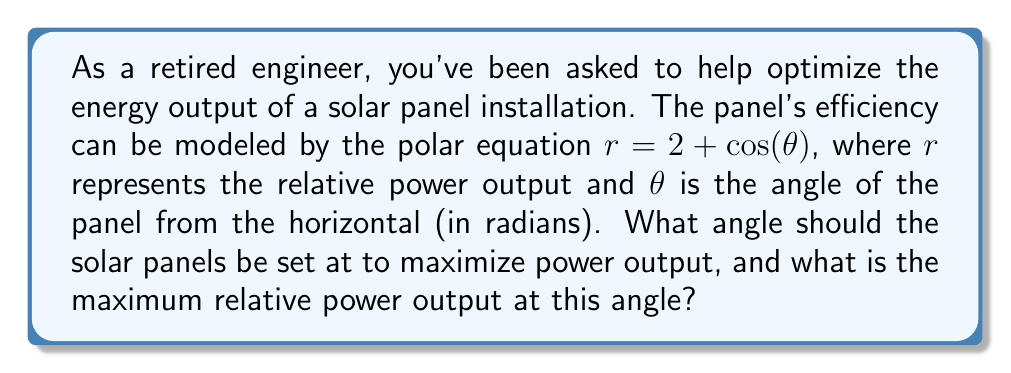Show me your answer to this math problem. To solve this problem, we need to find the maximum value of $r$ in the given polar equation. This can be done by following these steps:

1) The polar equation is given as:
   $$r = 2 + \cos(\theta)$$

2) To find the maximum value of $r$, we need to find where $\frac{dr}{d\theta} = 0$:
   $$\frac{dr}{d\theta} = -\sin(\theta)$$

3) Setting this equal to zero:
   $$-\sin(\theta) = 0$$

4) The sine function is zero when $\theta = 0, \pi, 2\pi, \text{etc.}$ In the context of solar panels, we're interested in the angle between 0 and $\pi$ (0° to 180°).

5) To determine which of these gives the maximum, we can check the second derivative:
   $$\frac{d^2r}{d\theta^2} = -\cos(\theta)$$

6) At $\theta = 0$, $\frac{d^2r}{d\theta^2} = -1 < 0$, indicating a maximum.
   At $\theta = \pi$, $\frac{d^2r}{d\theta^2} = 1 > 0$, indicating a minimum.

7) Therefore, the maximum occurs at $\theta = 0$ radians or 0°.

8) To find the maximum relative power output, we substitute $\theta = 0$ into the original equation:
   $$r = 2 + \cos(0) = 2 + 1 = 3$$

[asy]
import graph;
size(200);
real r(real t) {return 2+cos(t);}
draw(polargraph(r,0,2pi,operator ..),blue);
dot((3,0),red);
label("Maximum at $\theta = 0$, $r = 3$",(3,0),E);
[/asy]
Answer: The optimal angle for the solar panels is 0° (horizontal), and the maximum relative power output at this angle is 3. 